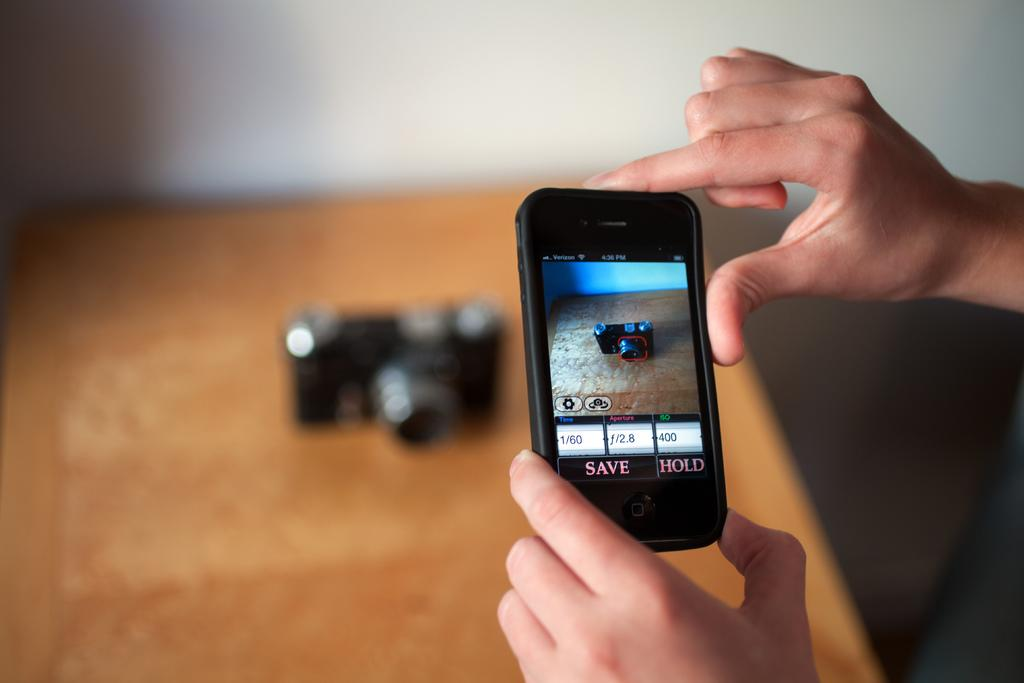<image>
Present a compact description of the photo's key features. A phone's camera app has the option to save or hold the current image. 